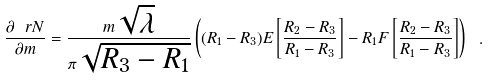Convert formula to latex. <formula><loc_0><loc_0><loc_500><loc_500>\frac { \partial \ r N } { \partial m } = \frac { m \sqrt { \lambda } } { \pi \sqrt { R _ { 3 } - R _ { 1 } } } \left ( ( R _ { 1 } - R _ { 3 } ) E \left [ \frac { R _ { 2 } - R _ { 3 } } { R _ { 1 } - R _ { 3 } } \right ] - R _ { 1 } F \left [ \frac { R _ { 2 } - R _ { 3 } } { R _ { 1 } - R _ { 3 } } \right ] \right ) \ .</formula> 